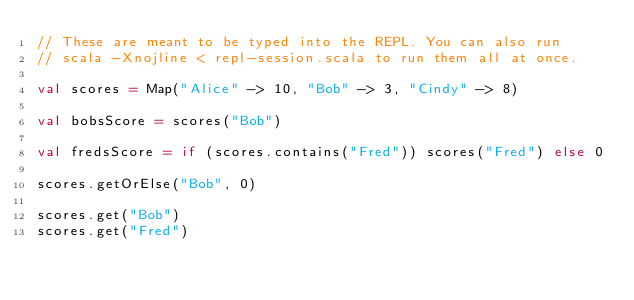<code> <loc_0><loc_0><loc_500><loc_500><_Scala_>// These are meant to be typed into the REPL. You can also run
// scala -Xnojline < repl-session.scala to run them all at once.

val scores = Map("Alice" -> 10, "Bob" -> 3, "Cindy" -> 8)

val bobsScore = scores("Bob")

val fredsScore = if (scores.contains("Fred")) scores("Fred") else 0

scores.getOrElse("Bob", 0)

scores.get("Bob")
scores.get("Fred")
</code> 